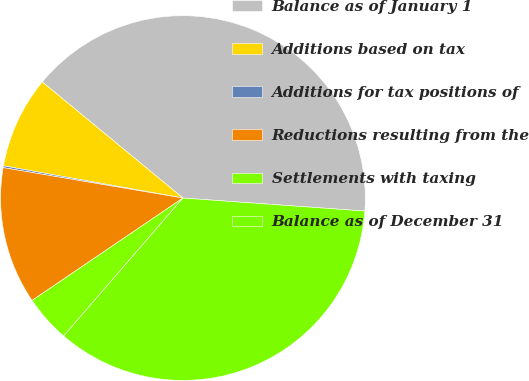Convert chart. <chart><loc_0><loc_0><loc_500><loc_500><pie_chart><fcel>Balance as of January 1<fcel>Additions based on tax<fcel>Additions for tax positions of<fcel>Reductions resulting from the<fcel>Settlements with taxing<fcel>Balance as of December 31<nl><fcel>40.16%<fcel>8.16%<fcel>0.16%<fcel>12.16%<fcel>4.16%<fcel>35.22%<nl></chart> 